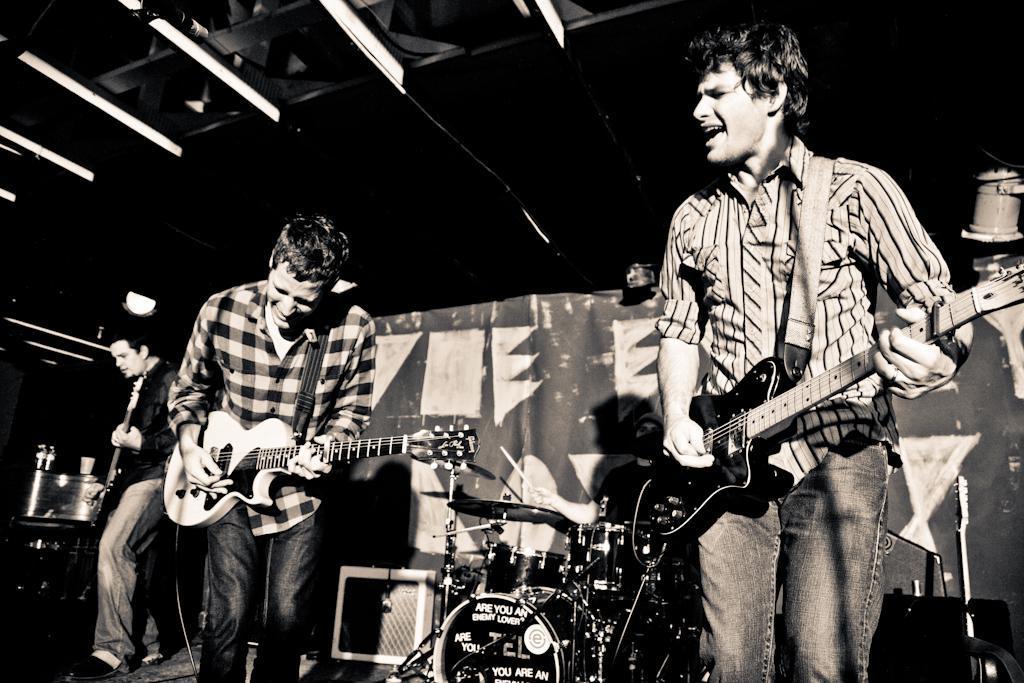Can you describe this image briefly? We can few people are playing a musical instrument. There is a banner at the back side. We can see lights here and here. 